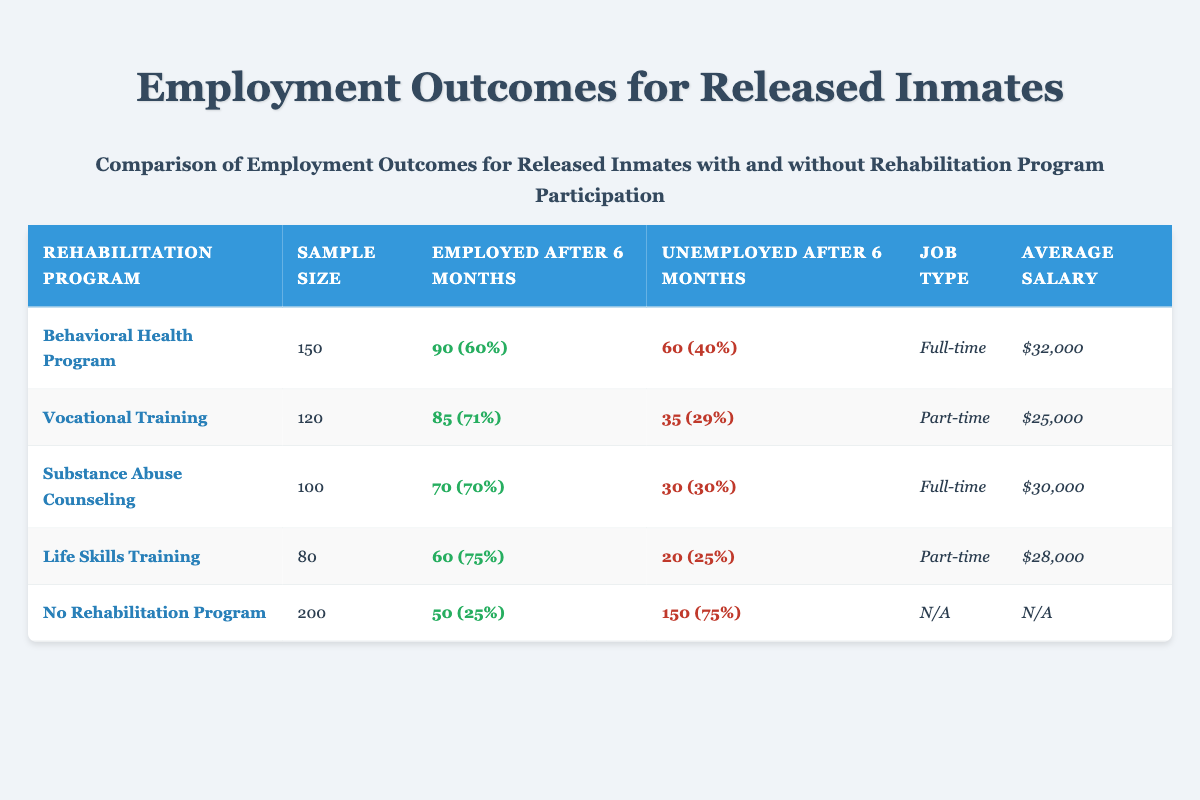What is the sample size for the Behavioral Health Program? The sample size for the Behavioral Health Program is directly stated in the table under the "Sample Size" column. It shows a value of 150.
Answer: 150 What percentage of participants in the Life Skills Training program were employed after 6 months? The table indicates that 60 participants were employed after 6 months from a sample size of 80. To find the percentage, we use the formula (60/80) * 100 = 75%.
Answer: 75% Is the average salary for participants in the Vocational Training program higher than those who did not participate in any rehabilitation program? The average salary for the Vocational Training program is $25,000, while for individuals with no rehabilitation program, it is listed as N/A. Since there is no numeric value for the average salary in the "No Rehabilitation Program" row, we cannot say whether it's higher or lower.
Answer: No What is the total number of unemployed individuals after 6 months among all rehabilitation programs listed? We sum the number of unemployed individuals after 6 months from each program: 60 (Behavioral Health) + 35 (Vocational Training) + 30 (Substance Abuse Counseling) + 20 (Life Skills Training) + 150 (No Rehabilitation Program) = 295.
Answer: 295 Among the programs, which has the highest employment rate? We calculate the employment rates for each program: Behavioral Health Program (90/150 = 60%), Vocational Training (85/120 = 71%), Substance Abuse Counseling (70/100 = 70%), Life Skills Training (60/80 = 75%), and No Rehabilitation Program (50/200 = 25%). The Life Skills Training program has the highest employment rate at 75%.
Answer: Life Skills Training 